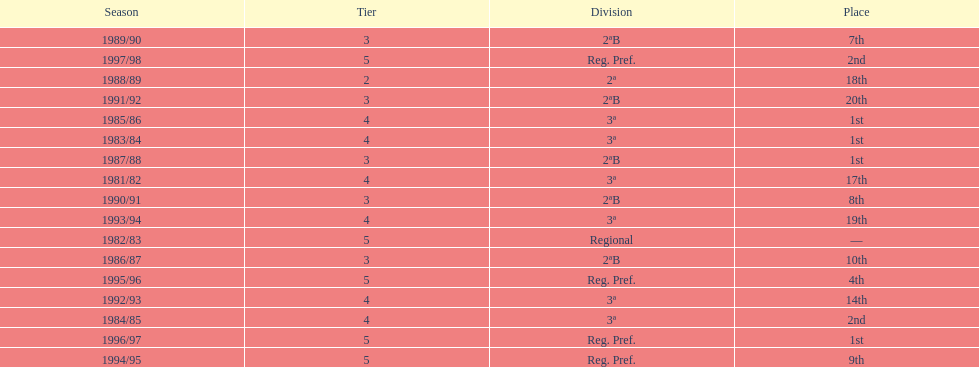How many times total did they finish first 4. 